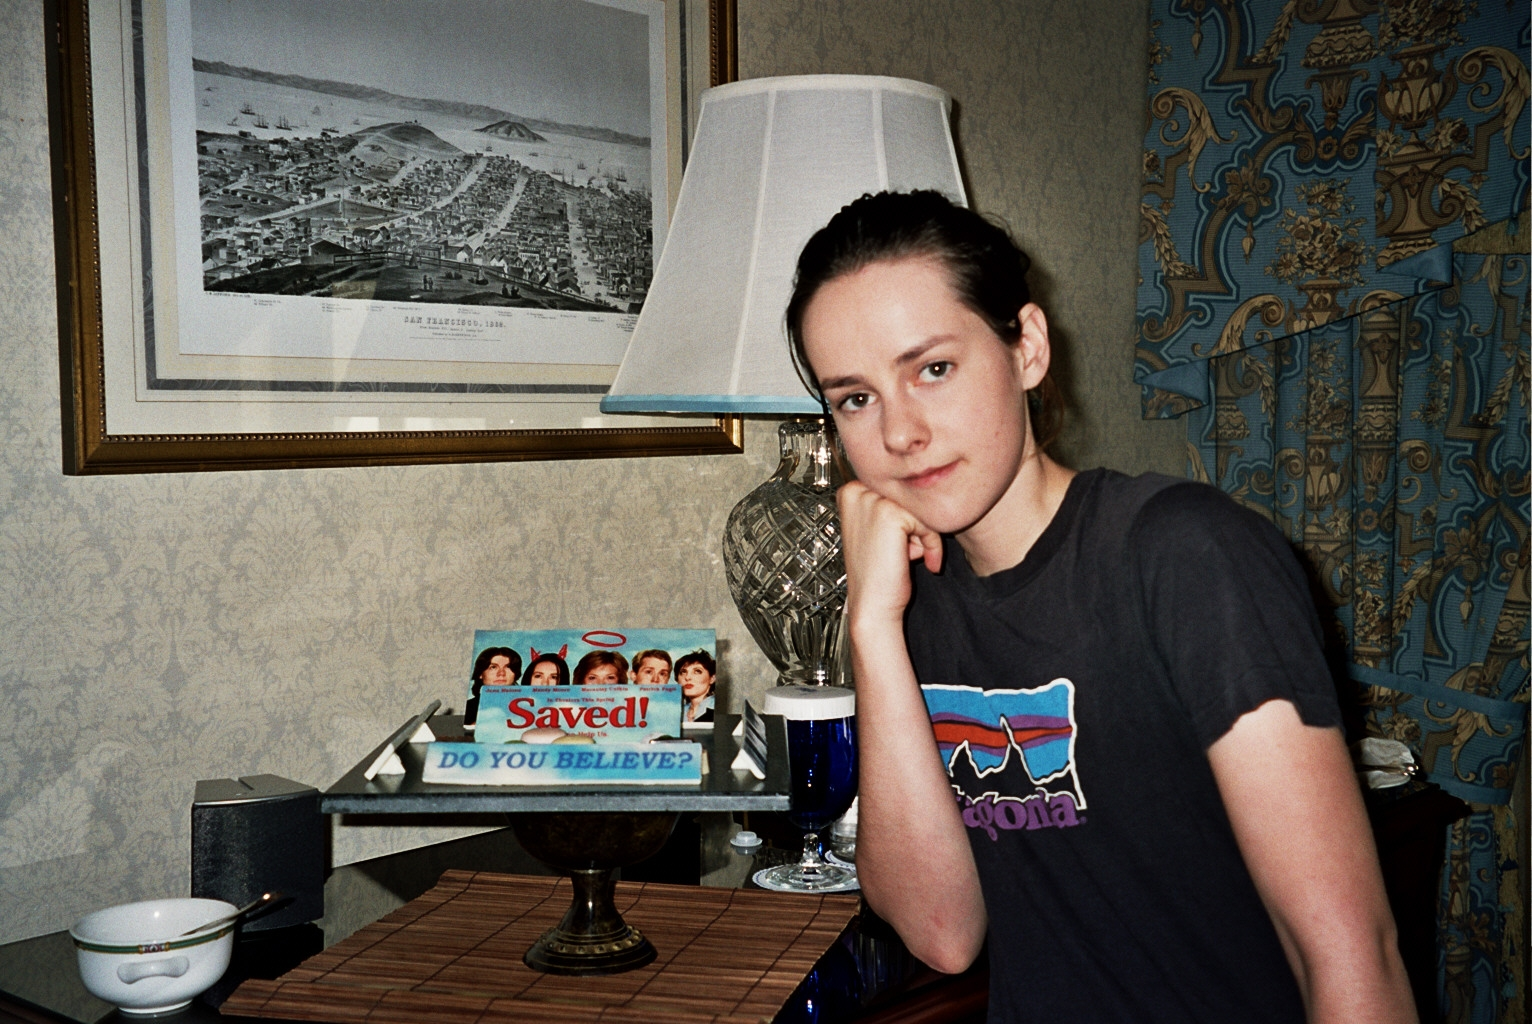Imagine and describe a day in the life of the individual in this picture. The individual in this picture may start their day with a refreshing hike, given the 'Patagonia' t-shirt that hints at a love for the outdoors. They then return home to a warmly lit room, where they might enjoy a cup of tea while reading a newspaper or watching a classic movie like 'Saved!'. Their day is filled with moments of reflection and relaxation, surrounded by personal and historical artifacts that bring comfort and a sense of identity. 